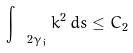<formula> <loc_0><loc_0><loc_500><loc_500>\int _ { \ 2 { \gamma } _ { j } } k ^ { 2 } \, d s \leq C _ { 2 }</formula> 